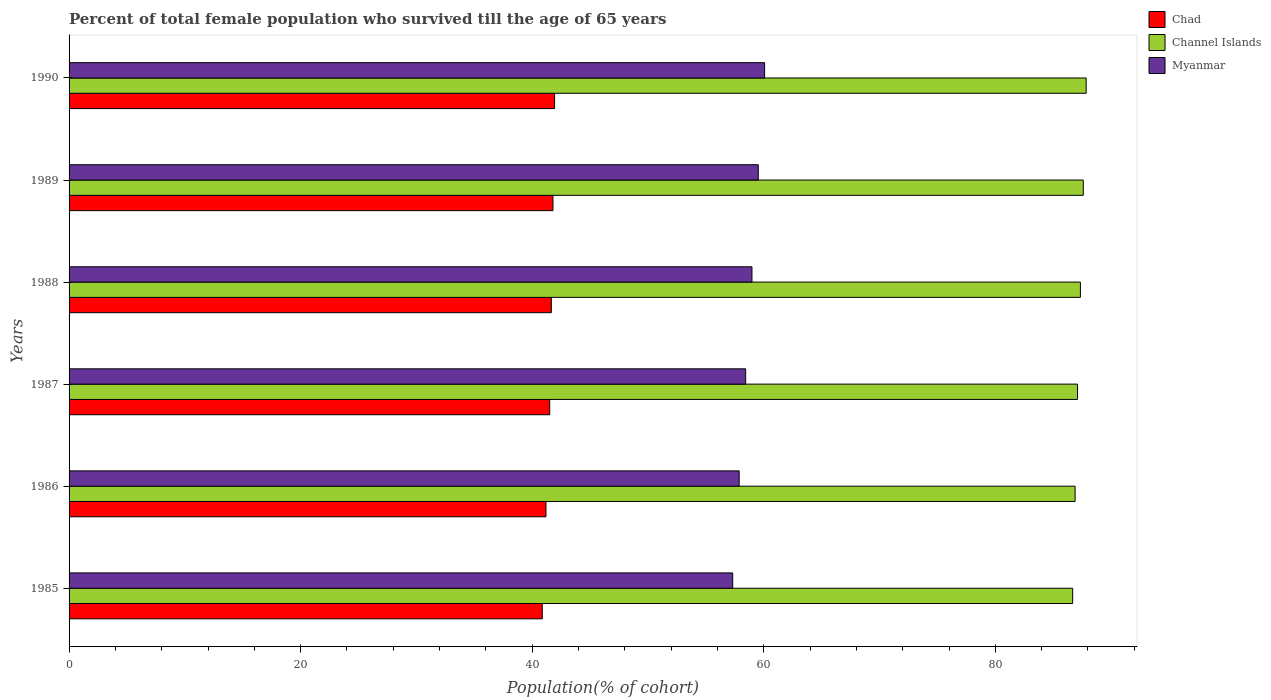How many different coloured bars are there?
Provide a succinct answer. 3. Are the number of bars per tick equal to the number of legend labels?
Give a very brief answer. Yes. Are the number of bars on each tick of the Y-axis equal?
Offer a very short reply. Yes. How many bars are there on the 1st tick from the top?
Your answer should be compact. 3. What is the label of the 1st group of bars from the top?
Your answer should be very brief. 1990. In how many cases, is the number of bars for a given year not equal to the number of legend labels?
Your answer should be very brief. 0. What is the percentage of total female population who survived till the age of 65 years in Myanmar in 1987?
Offer a terse response. 58.44. Across all years, what is the maximum percentage of total female population who survived till the age of 65 years in Chad?
Provide a short and direct response. 41.93. Across all years, what is the minimum percentage of total female population who survived till the age of 65 years in Channel Islands?
Offer a very short reply. 86.68. In which year was the percentage of total female population who survived till the age of 65 years in Channel Islands maximum?
Offer a terse response. 1990. In which year was the percentage of total female population who survived till the age of 65 years in Channel Islands minimum?
Ensure brevity in your answer.  1985. What is the total percentage of total female population who survived till the age of 65 years in Chad in the graph?
Ensure brevity in your answer.  248.95. What is the difference between the percentage of total female population who survived till the age of 65 years in Chad in 1986 and that in 1990?
Your answer should be very brief. -0.74. What is the difference between the percentage of total female population who survived till the age of 65 years in Myanmar in 1990 and the percentage of total female population who survived till the age of 65 years in Chad in 1989?
Offer a terse response. 18.28. What is the average percentage of total female population who survived till the age of 65 years in Chad per year?
Ensure brevity in your answer.  41.49. In the year 1990, what is the difference between the percentage of total female population who survived till the age of 65 years in Chad and percentage of total female population who survived till the age of 65 years in Channel Islands?
Give a very brief answer. -45.91. What is the ratio of the percentage of total female population who survived till the age of 65 years in Channel Islands in 1987 to that in 1989?
Provide a succinct answer. 0.99. Is the percentage of total female population who survived till the age of 65 years in Channel Islands in 1985 less than that in 1987?
Your answer should be compact. Yes. Is the difference between the percentage of total female population who survived till the age of 65 years in Chad in 1986 and 1988 greater than the difference between the percentage of total female population who survived till the age of 65 years in Channel Islands in 1986 and 1988?
Your response must be concise. No. What is the difference between the highest and the second highest percentage of total female population who survived till the age of 65 years in Channel Islands?
Make the answer very short. 0.25. What is the difference between the highest and the lowest percentage of total female population who survived till the age of 65 years in Channel Islands?
Provide a short and direct response. 1.16. What does the 1st bar from the top in 1989 represents?
Ensure brevity in your answer.  Myanmar. What does the 1st bar from the bottom in 1987 represents?
Give a very brief answer. Chad. Is it the case that in every year, the sum of the percentage of total female population who survived till the age of 65 years in Channel Islands and percentage of total female population who survived till the age of 65 years in Myanmar is greater than the percentage of total female population who survived till the age of 65 years in Chad?
Make the answer very short. Yes. How many years are there in the graph?
Make the answer very short. 6. What is the difference between two consecutive major ticks on the X-axis?
Make the answer very short. 20. Does the graph contain grids?
Your answer should be compact. No. Where does the legend appear in the graph?
Ensure brevity in your answer.  Top right. How many legend labels are there?
Provide a short and direct response. 3. How are the legend labels stacked?
Your answer should be very brief. Vertical. What is the title of the graph?
Your answer should be very brief. Percent of total female population who survived till the age of 65 years. What is the label or title of the X-axis?
Your answer should be compact. Population(% of cohort). What is the Population(% of cohort) of Chad in 1985?
Give a very brief answer. 40.87. What is the Population(% of cohort) of Channel Islands in 1985?
Your answer should be compact. 86.68. What is the Population(% of cohort) of Myanmar in 1985?
Offer a very short reply. 57.32. What is the Population(% of cohort) in Chad in 1986?
Your answer should be very brief. 41.19. What is the Population(% of cohort) in Channel Islands in 1986?
Your answer should be very brief. 86.89. What is the Population(% of cohort) in Myanmar in 1986?
Offer a very short reply. 57.88. What is the Population(% of cohort) of Chad in 1987?
Your answer should be very brief. 41.51. What is the Population(% of cohort) in Channel Islands in 1987?
Make the answer very short. 87.1. What is the Population(% of cohort) of Myanmar in 1987?
Give a very brief answer. 58.44. What is the Population(% of cohort) of Chad in 1988?
Ensure brevity in your answer.  41.65. What is the Population(% of cohort) of Channel Islands in 1988?
Offer a very short reply. 87.35. What is the Population(% of cohort) of Myanmar in 1988?
Offer a terse response. 58.98. What is the Population(% of cohort) of Chad in 1989?
Your answer should be very brief. 41.79. What is the Population(% of cohort) of Channel Islands in 1989?
Keep it short and to the point. 87.6. What is the Population(% of cohort) in Myanmar in 1989?
Ensure brevity in your answer.  59.53. What is the Population(% of cohort) of Chad in 1990?
Your answer should be very brief. 41.93. What is the Population(% of cohort) of Channel Islands in 1990?
Your response must be concise. 87.84. What is the Population(% of cohort) in Myanmar in 1990?
Give a very brief answer. 60.07. Across all years, what is the maximum Population(% of cohort) of Chad?
Your answer should be very brief. 41.93. Across all years, what is the maximum Population(% of cohort) of Channel Islands?
Make the answer very short. 87.84. Across all years, what is the maximum Population(% of cohort) in Myanmar?
Keep it short and to the point. 60.07. Across all years, what is the minimum Population(% of cohort) in Chad?
Provide a succinct answer. 40.87. Across all years, what is the minimum Population(% of cohort) of Channel Islands?
Provide a short and direct response. 86.68. Across all years, what is the minimum Population(% of cohort) of Myanmar?
Make the answer very short. 57.32. What is the total Population(% of cohort) in Chad in the graph?
Give a very brief answer. 248.95. What is the total Population(% of cohort) in Channel Islands in the graph?
Provide a short and direct response. 523.45. What is the total Population(% of cohort) of Myanmar in the graph?
Your answer should be compact. 352.2. What is the difference between the Population(% of cohort) in Chad in 1985 and that in 1986?
Your response must be concise. -0.32. What is the difference between the Population(% of cohort) in Channel Islands in 1985 and that in 1986?
Give a very brief answer. -0.21. What is the difference between the Population(% of cohort) of Myanmar in 1985 and that in 1986?
Your answer should be compact. -0.56. What is the difference between the Population(% of cohort) of Chad in 1985 and that in 1987?
Your answer should be very brief. -0.64. What is the difference between the Population(% of cohort) in Channel Islands in 1985 and that in 1987?
Provide a short and direct response. -0.42. What is the difference between the Population(% of cohort) of Myanmar in 1985 and that in 1987?
Offer a very short reply. -1.12. What is the difference between the Population(% of cohort) of Chad in 1985 and that in 1988?
Your answer should be compact. -0.78. What is the difference between the Population(% of cohort) in Channel Islands in 1985 and that in 1988?
Keep it short and to the point. -0.67. What is the difference between the Population(% of cohort) of Myanmar in 1985 and that in 1988?
Your answer should be very brief. -1.66. What is the difference between the Population(% of cohort) in Chad in 1985 and that in 1989?
Provide a short and direct response. -0.92. What is the difference between the Population(% of cohort) in Channel Islands in 1985 and that in 1989?
Provide a succinct answer. -0.92. What is the difference between the Population(% of cohort) of Myanmar in 1985 and that in 1989?
Your answer should be compact. -2.21. What is the difference between the Population(% of cohort) of Chad in 1985 and that in 1990?
Make the answer very short. -1.06. What is the difference between the Population(% of cohort) of Channel Islands in 1985 and that in 1990?
Your answer should be very brief. -1.16. What is the difference between the Population(% of cohort) in Myanmar in 1985 and that in 1990?
Make the answer very short. -2.76. What is the difference between the Population(% of cohort) in Chad in 1986 and that in 1987?
Offer a terse response. -0.32. What is the difference between the Population(% of cohort) of Channel Islands in 1986 and that in 1987?
Your response must be concise. -0.21. What is the difference between the Population(% of cohort) in Myanmar in 1986 and that in 1987?
Provide a short and direct response. -0.56. What is the difference between the Population(% of cohort) in Chad in 1986 and that in 1988?
Your response must be concise. -0.46. What is the difference between the Population(% of cohort) in Channel Islands in 1986 and that in 1988?
Your response must be concise. -0.46. What is the difference between the Population(% of cohort) of Myanmar in 1986 and that in 1988?
Ensure brevity in your answer.  -1.1. What is the difference between the Population(% of cohort) of Chad in 1986 and that in 1989?
Offer a terse response. -0.6. What is the difference between the Population(% of cohort) of Channel Islands in 1986 and that in 1989?
Make the answer very short. -0.71. What is the difference between the Population(% of cohort) of Myanmar in 1986 and that in 1989?
Your response must be concise. -1.65. What is the difference between the Population(% of cohort) of Chad in 1986 and that in 1990?
Your response must be concise. -0.74. What is the difference between the Population(% of cohort) in Channel Islands in 1986 and that in 1990?
Make the answer very short. -0.95. What is the difference between the Population(% of cohort) of Myanmar in 1986 and that in 1990?
Ensure brevity in your answer.  -2.2. What is the difference between the Population(% of cohort) in Chad in 1987 and that in 1988?
Provide a succinct answer. -0.14. What is the difference between the Population(% of cohort) of Channel Islands in 1987 and that in 1988?
Your response must be concise. -0.25. What is the difference between the Population(% of cohort) in Myanmar in 1987 and that in 1988?
Your response must be concise. -0.55. What is the difference between the Population(% of cohort) of Chad in 1987 and that in 1989?
Provide a succinct answer. -0.28. What is the difference between the Population(% of cohort) in Channel Islands in 1987 and that in 1989?
Keep it short and to the point. -0.5. What is the difference between the Population(% of cohort) in Myanmar in 1987 and that in 1989?
Provide a succinct answer. -1.09. What is the difference between the Population(% of cohort) of Chad in 1987 and that in 1990?
Provide a short and direct response. -0.42. What is the difference between the Population(% of cohort) of Channel Islands in 1987 and that in 1990?
Offer a very short reply. -0.74. What is the difference between the Population(% of cohort) in Myanmar in 1987 and that in 1990?
Provide a succinct answer. -1.64. What is the difference between the Population(% of cohort) in Chad in 1988 and that in 1989?
Give a very brief answer. -0.14. What is the difference between the Population(% of cohort) of Channel Islands in 1988 and that in 1989?
Make the answer very short. -0.25. What is the difference between the Population(% of cohort) of Myanmar in 1988 and that in 1989?
Provide a short and direct response. -0.55. What is the difference between the Population(% of cohort) of Chad in 1988 and that in 1990?
Provide a succinct answer. -0.28. What is the difference between the Population(% of cohort) of Channel Islands in 1988 and that in 1990?
Provide a succinct answer. -0.5. What is the difference between the Population(% of cohort) in Myanmar in 1988 and that in 1990?
Give a very brief answer. -1.09. What is the difference between the Population(% of cohort) of Chad in 1989 and that in 1990?
Keep it short and to the point. -0.14. What is the difference between the Population(% of cohort) in Channel Islands in 1989 and that in 1990?
Offer a very short reply. -0.25. What is the difference between the Population(% of cohort) in Myanmar in 1989 and that in 1990?
Your answer should be compact. -0.55. What is the difference between the Population(% of cohort) of Chad in 1985 and the Population(% of cohort) of Channel Islands in 1986?
Offer a very short reply. -46.02. What is the difference between the Population(% of cohort) in Chad in 1985 and the Population(% of cohort) in Myanmar in 1986?
Your response must be concise. -17.01. What is the difference between the Population(% of cohort) of Channel Islands in 1985 and the Population(% of cohort) of Myanmar in 1986?
Your answer should be very brief. 28.8. What is the difference between the Population(% of cohort) in Chad in 1985 and the Population(% of cohort) in Channel Islands in 1987?
Provide a succinct answer. -46.23. What is the difference between the Population(% of cohort) in Chad in 1985 and the Population(% of cohort) in Myanmar in 1987?
Offer a very short reply. -17.57. What is the difference between the Population(% of cohort) of Channel Islands in 1985 and the Population(% of cohort) of Myanmar in 1987?
Your answer should be very brief. 28.24. What is the difference between the Population(% of cohort) in Chad in 1985 and the Population(% of cohort) in Channel Islands in 1988?
Make the answer very short. -46.48. What is the difference between the Population(% of cohort) in Chad in 1985 and the Population(% of cohort) in Myanmar in 1988?
Offer a very short reply. -18.11. What is the difference between the Population(% of cohort) of Channel Islands in 1985 and the Population(% of cohort) of Myanmar in 1988?
Provide a short and direct response. 27.7. What is the difference between the Population(% of cohort) of Chad in 1985 and the Population(% of cohort) of Channel Islands in 1989?
Make the answer very short. -46.73. What is the difference between the Population(% of cohort) of Chad in 1985 and the Population(% of cohort) of Myanmar in 1989?
Your answer should be very brief. -18.66. What is the difference between the Population(% of cohort) of Channel Islands in 1985 and the Population(% of cohort) of Myanmar in 1989?
Your answer should be compact. 27.15. What is the difference between the Population(% of cohort) of Chad in 1985 and the Population(% of cohort) of Channel Islands in 1990?
Offer a very short reply. -46.97. What is the difference between the Population(% of cohort) of Chad in 1985 and the Population(% of cohort) of Myanmar in 1990?
Your answer should be very brief. -19.2. What is the difference between the Population(% of cohort) in Channel Islands in 1985 and the Population(% of cohort) in Myanmar in 1990?
Keep it short and to the point. 26.61. What is the difference between the Population(% of cohort) in Chad in 1986 and the Population(% of cohort) in Channel Islands in 1987?
Ensure brevity in your answer.  -45.91. What is the difference between the Population(% of cohort) of Chad in 1986 and the Population(% of cohort) of Myanmar in 1987?
Ensure brevity in your answer.  -17.25. What is the difference between the Population(% of cohort) of Channel Islands in 1986 and the Population(% of cohort) of Myanmar in 1987?
Offer a very short reply. 28.45. What is the difference between the Population(% of cohort) of Chad in 1986 and the Population(% of cohort) of Channel Islands in 1988?
Keep it short and to the point. -46.16. What is the difference between the Population(% of cohort) of Chad in 1986 and the Population(% of cohort) of Myanmar in 1988?
Your answer should be very brief. -17.79. What is the difference between the Population(% of cohort) in Channel Islands in 1986 and the Population(% of cohort) in Myanmar in 1988?
Keep it short and to the point. 27.91. What is the difference between the Population(% of cohort) in Chad in 1986 and the Population(% of cohort) in Channel Islands in 1989?
Your answer should be very brief. -46.41. What is the difference between the Population(% of cohort) of Chad in 1986 and the Population(% of cohort) of Myanmar in 1989?
Make the answer very short. -18.34. What is the difference between the Population(% of cohort) of Channel Islands in 1986 and the Population(% of cohort) of Myanmar in 1989?
Your answer should be very brief. 27.36. What is the difference between the Population(% of cohort) in Chad in 1986 and the Population(% of cohort) in Channel Islands in 1990?
Your answer should be compact. -46.65. What is the difference between the Population(% of cohort) of Chad in 1986 and the Population(% of cohort) of Myanmar in 1990?
Offer a very short reply. -18.88. What is the difference between the Population(% of cohort) of Channel Islands in 1986 and the Population(% of cohort) of Myanmar in 1990?
Offer a terse response. 26.82. What is the difference between the Population(% of cohort) in Chad in 1987 and the Population(% of cohort) in Channel Islands in 1988?
Make the answer very short. -45.84. What is the difference between the Population(% of cohort) of Chad in 1987 and the Population(% of cohort) of Myanmar in 1988?
Keep it short and to the point. -17.47. What is the difference between the Population(% of cohort) of Channel Islands in 1987 and the Population(% of cohort) of Myanmar in 1988?
Offer a very short reply. 28.12. What is the difference between the Population(% of cohort) in Chad in 1987 and the Population(% of cohort) in Channel Islands in 1989?
Ensure brevity in your answer.  -46.08. What is the difference between the Population(% of cohort) in Chad in 1987 and the Population(% of cohort) in Myanmar in 1989?
Your answer should be very brief. -18.01. What is the difference between the Population(% of cohort) of Channel Islands in 1987 and the Population(% of cohort) of Myanmar in 1989?
Your answer should be compact. 27.57. What is the difference between the Population(% of cohort) in Chad in 1987 and the Population(% of cohort) in Channel Islands in 1990?
Offer a very short reply. -46.33. What is the difference between the Population(% of cohort) in Chad in 1987 and the Population(% of cohort) in Myanmar in 1990?
Make the answer very short. -18.56. What is the difference between the Population(% of cohort) of Channel Islands in 1987 and the Population(% of cohort) of Myanmar in 1990?
Offer a very short reply. 27.03. What is the difference between the Population(% of cohort) of Chad in 1988 and the Population(% of cohort) of Channel Islands in 1989?
Your response must be concise. -45.94. What is the difference between the Population(% of cohort) in Chad in 1988 and the Population(% of cohort) in Myanmar in 1989?
Offer a very short reply. -17.87. What is the difference between the Population(% of cohort) in Channel Islands in 1988 and the Population(% of cohort) in Myanmar in 1989?
Offer a very short reply. 27.82. What is the difference between the Population(% of cohort) of Chad in 1988 and the Population(% of cohort) of Channel Islands in 1990?
Your answer should be very brief. -46.19. What is the difference between the Population(% of cohort) of Chad in 1988 and the Population(% of cohort) of Myanmar in 1990?
Provide a succinct answer. -18.42. What is the difference between the Population(% of cohort) of Channel Islands in 1988 and the Population(% of cohort) of Myanmar in 1990?
Your answer should be compact. 27.28. What is the difference between the Population(% of cohort) in Chad in 1989 and the Population(% of cohort) in Channel Islands in 1990?
Ensure brevity in your answer.  -46.05. What is the difference between the Population(% of cohort) of Chad in 1989 and the Population(% of cohort) of Myanmar in 1990?
Give a very brief answer. -18.28. What is the difference between the Population(% of cohort) in Channel Islands in 1989 and the Population(% of cohort) in Myanmar in 1990?
Make the answer very short. 27.52. What is the average Population(% of cohort) in Chad per year?
Give a very brief answer. 41.49. What is the average Population(% of cohort) in Channel Islands per year?
Give a very brief answer. 87.24. What is the average Population(% of cohort) in Myanmar per year?
Keep it short and to the point. 58.7. In the year 1985, what is the difference between the Population(% of cohort) in Chad and Population(% of cohort) in Channel Islands?
Offer a very short reply. -45.81. In the year 1985, what is the difference between the Population(% of cohort) in Chad and Population(% of cohort) in Myanmar?
Provide a short and direct response. -16.45. In the year 1985, what is the difference between the Population(% of cohort) in Channel Islands and Population(% of cohort) in Myanmar?
Make the answer very short. 29.36. In the year 1986, what is the difference between the Population(% of cohort) in Chad and Population(% of cohort) in Channel Islands?
Offer a very short reply. -45.7. In the year 1986, what is the difference between the Population(% of cohort) in Chad and Population(% of cohort) in Myanmar?
Your answer should be very brief. -16.69. In the year 1986, what is the difference between the Population(% of cohort) in Channel Islands and Population(% of cohort) in Myanmar?
Offer a terse response. 29.01. In the year 1987, what is the difference between the Population(% of cohort) of Chad and Population(% of cohort) of Channel Islands?
Your answer should be compact. -45.59. In the year 1987, what is the difference between the Population(% of cohort) of Chad and Population(% of cohort) of Myanmar?
Keep it short and to the point. -16.92. In the year 1987, what is the difference between the Population(% of cohort) of Channel Islands and Population(% of cohort) of Myanmar?
Keep it short and to the point. 28.66. In the year 1988, what is the difference between the Population(% of cohort) in Chad and Population(% of cohort) in Channel Islands?
Your response must be concise. -45.7. In the year 1988, what is the difference between the Population(% of cohort) of Chad and Population(% of cohort) of Myanmar?
Provide a succinct answer. -17.33. In the year 1988, what is the difference between the Population(% of cohort) of Channel Islands and Population(% of cohort) of Myanmar?
Your answer should be very brief. 28.37. In the year 1989, what is the difference between the Population(% of cohort) of Chad and Population(% of cohort) of Channel Islands?
Your answer should be compact. -45.8. In the year 1989, what is the difference between the Population(% of cohort) in Chad and Population(% of cohort) in Myanmar?
Provide a succinct answer. -17.73. In the year 1989, what is the difference between the Population(% of cohort) in Channel Islands and Population(% of cohort) in Myanmar?
Make the answer very short. 28.07. In the year 1990, what is the difference between the Population(% of cohort) of Chad and Population(% of cohort) of Channel Islands?
Provide a succinct answer. -45.91. In the year 1990, what is the difference between the Population(% of cohort) in Chad and Population(% of cohort) in Myanmar?
Keep it short and to the point. -18.14. In the year 1990, what is the difference between the Population(% of cohort) in Channel Islands and Population(% of cohort) in Myanmar?
Offer a terse response. 27.77. What is the ratio of the Population(% of cohort) in Chad in 1985 to that in 1986?
Make the answer very short. 0.99. What is the ratio of the Population(% of cohort) of Channel Islands in 1985 to that in 1986?
Offer a very short reply. 1. What is the ratio of the Population(% of cohort) in Myanmar in 1985 to that in 1986?
Offer a very short reply. 0.99. What is the ratio of the Population(% of cohort) in Chad in 1985 to that in 1987?
Your response must be concise. 0.98. What is the ratio of the Population(% of cohort) of Channel Islands in 1985 to that in 1987?
Your answer should be compact. 1. What is the ratio of the Population(% of cohort) in Myanmar in 1985 to that in 1987?
Offer a terse response. 0.98. What is the ratio of the Population(% of cohort) in Chad in 1985 to that in 1988?
Provide a succinct answer. 0.98. What is the ratio of the Population(% of cohort) in Myanmar in 1985 to that in 1988?
Keep it short and to the point. 0.97. What is the ratio of the Population(% of cohort) in Chad in 1985 to that in 1989?
Your answer should be very brief. 0.98. What is the ratio of the Population(% of cohort) in Myanmar in 1985 to that in 1989?
Offer a terse response. 0.96. What is the ratio of the Population(% of cohort) in Chad in 1985 to that in 1990?
Give a very brief answer. 0.97. What is the ratio of the Population(% of cohort) in Channel Islands in 1985 to that in 1990?
Provide a short and direct response. 0.99. What is the ratio of the Population(% of cohort) of Myanmar in 1985 to that in 1990?
Provide a short and direct response. 0.95. What is the ratio of the Population(% of cohort) of Channel Islands in 1986 to that in 1987?
Your answer should be very brief. 1. What is the ratio of the Population(% of cohort) of Myanmar in 1986 to that in 1987?
Your response must be concise. 0.99. What is the ratio of the Population(% of cohort) of Chad in 1986 to that in 1988?
Give a very brief answer. 0.99. What is the ratio of the Population(% of cohort) of Channel Islands in 1986 to that in 1988?
Offer a very short reply. 0.99. What is the ratio of the Population(% of cohort) in Myanmar in 1986 to that in 1988?
Offer a terse response. 0.98. What is the ratio of the Population(% of cohort) in Chad in 1986 to that in 1989?
Your answer should be compact. 0.99. What is the ratio of the Population(% of cohort) in Channel Islands in 1986 to that in 1989?
Offer a terse response. 0.99. What is the ratio of the Population(% of cohort) of Myanmar in 1986 to that in 1989?
Keep it short and to the point. 0.97. What is the ratio of the Population(% of cohort) of Chad in 1986 to that in 1990?
Your response must be concise. 0.98. What is the ratio of the Population(% of cohort) in Myanmar in 1986 to that in 1990?
Provide a short and direct response. 0.96. What is the ratio of the Population(% of cohort) in Chad in 1987 to that in 1988?
Ensure brevity in your answer.  1. What is the ratio of the Population(% of cohort) in Myanmar in 1987 to that in 1989?
Provide a succinct answer. 0.98. What is the ratio of the Population(% of cohort) of Chad in 1987 to that in 1990?
Give a very brief answer. 0.99. What is the ratio of the Population(% of cohort) in Myanmar in 1987 to that in 1990?
Your response must be concise. 0.97. What is the ratio of the Population(% of cohort) in Chad in 1988 to that in 1989?
Provide a short and direct response. 1. What is the ratio of the Population(% of cohort) of Myanmar in 1988 to that in 1989?
Keep it short and to the point. 0.99. What is the ratio of the Population(% of cohort) of Channel Islands in 1988 to that in 1990?
Make the answer very short. 0.99. What is the ratio of the Population(% of cohort) in Myanmar in 1988 to that in 1990?
Ensure brevity in your answer.  0.98. What is the ratio of the Population(% of cohort) of Chad in 1989 to that in 1990?
Offer a very short reply. 1. What is the ratio of the Population(% of cohort) in Myanmar in 1989 to that in 1990?
Ensure brevity in your answer.  0.99. What is the difference between the highest and the second highest Population(% of cohort) in Chad?
Provide a succinct answer. 0.14. What is the difference between the highest and the second highest Population(% of cohort) in Channel Islands?
Make the answer very short. 0.25. What is the difference between the highest and the second highest Population(% of cohort) of Myanmar?
Offer a very short reply. 0.55. What is the difference between the highest and the lowest Population(% of cohort) in Chad?
Your response must be concise. 1.06. What is the difference between the highest and the lowest Population(% of cohort) in Channel Islands?
Keep it short and to the point. 1.16. What is the difference between the highest and the lowest Population(% of cohort) in Myanmar?
Provide a short and direct response. 2.76. 